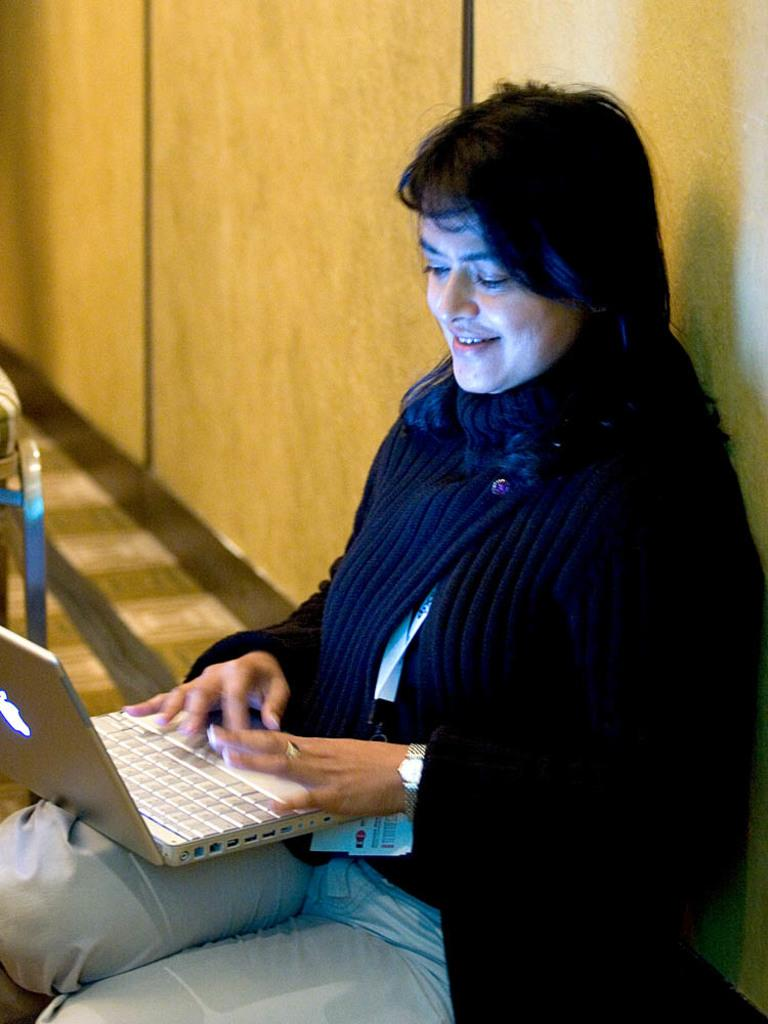Who is the main subject in the foreground of the image? There is a woman in the foreground of the image. What is the woman doing in the image? The woman is using a laptop. What can be seen in the background of the image? There is a wall in the background of the image. What type of scarecrow can be seen in the image? There is no scarecrow present in the image. What is the condition of the woman's health in the image? The image does not provide any information about the woman's health, so it cannot be determined from the image. 